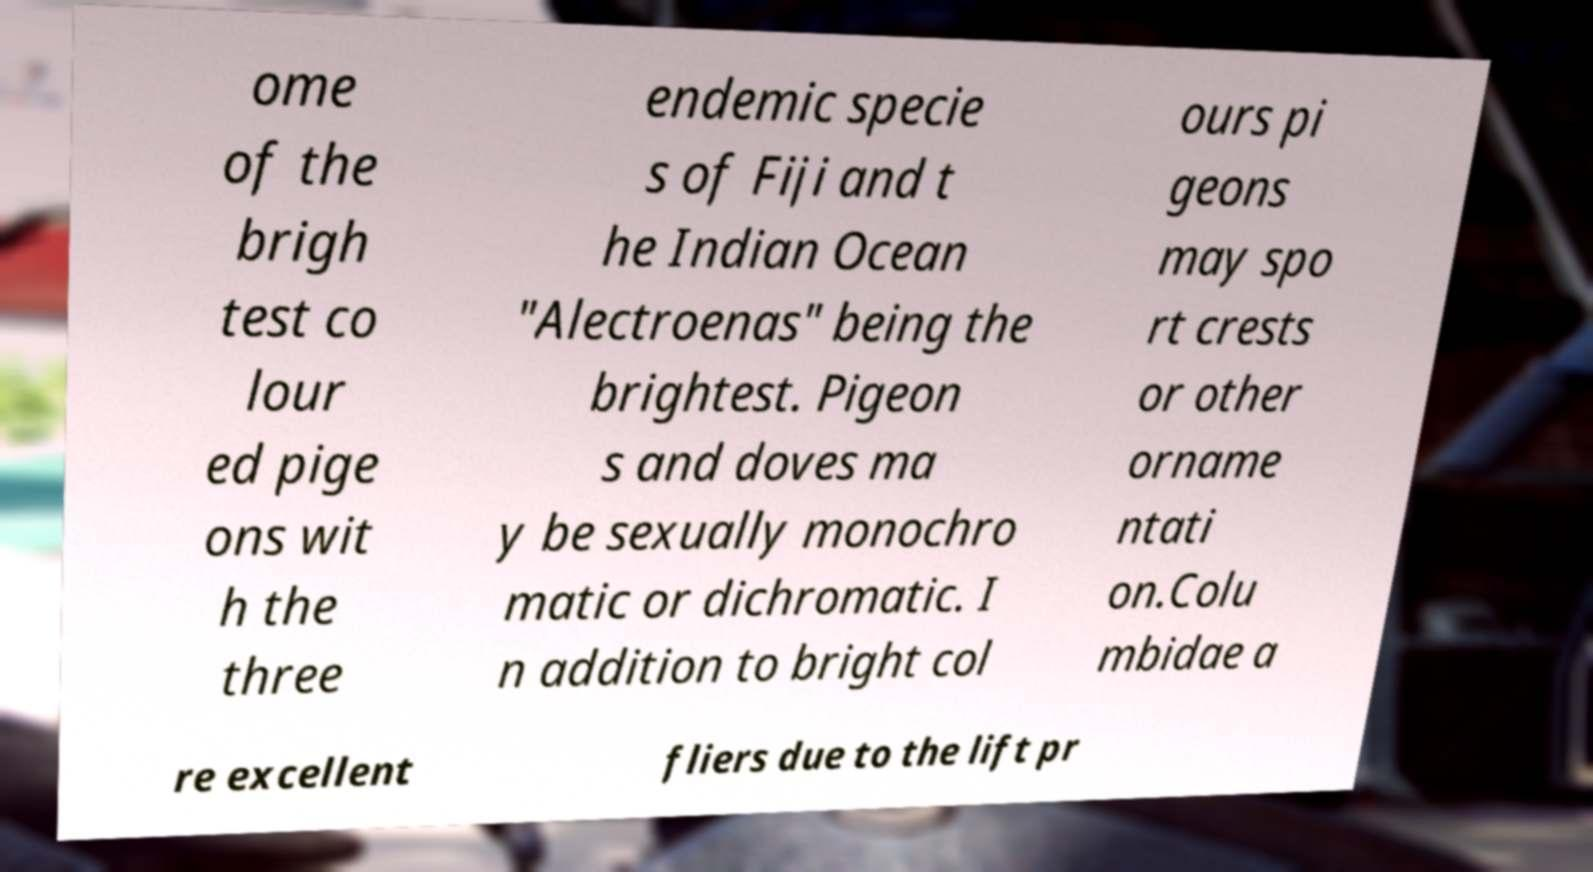Could you extract and type out the text from this image? ome of the brigh test co lour ed pige ons wit h the three endemic specie s of Fiji and t he Indian Ocean "Alectroenas" being the brightest. Pigeon s and doves ma y be sexually monochro matic or dichromatic. I n addition to bright col ours pi geons may spo rt crests or other orname ntati on.Colu mbidae a re excellent fliers due to the lift pr 